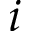<formula> <loc_0><loc_0><loc_500><loc_500>i</formula> 